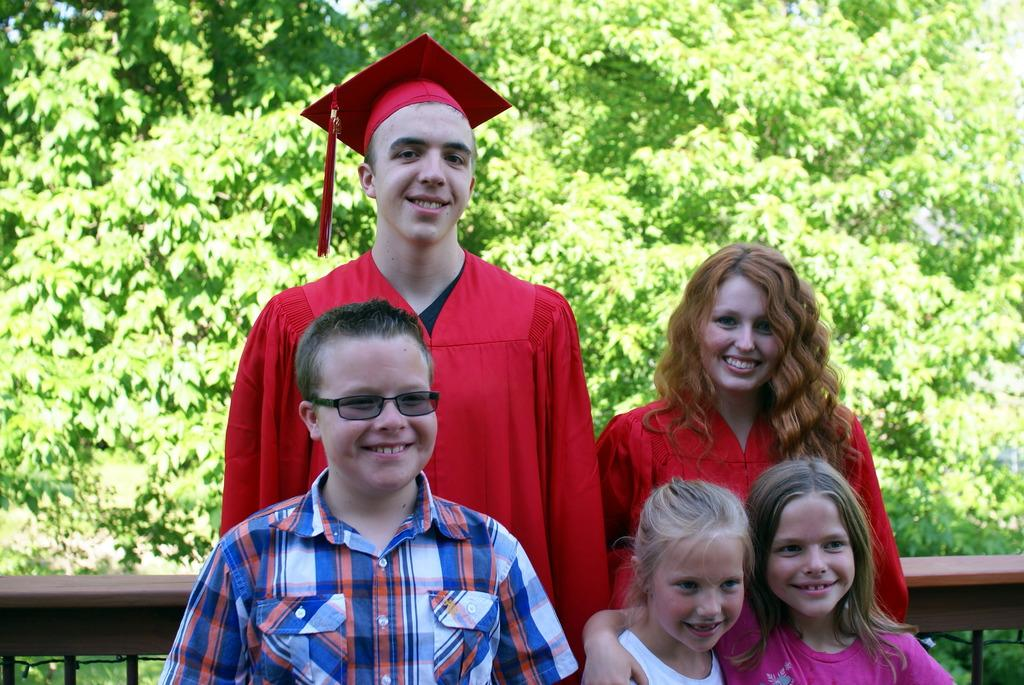How many people are in the image? There are five persons in the image. What is the facial expression of the people in the image? The persons are smiling. What type of barrier can be seen in the image? There is a kind of fence in the image. What can be seen in the background of the image? There are trees in the background of the image. What book is the person reading in the image? There is no person reading a book in the image. How does the lamp contribute to the balance of the scene? There is no lamp present in the image, so it cannot contribute to the balance of the scene. 